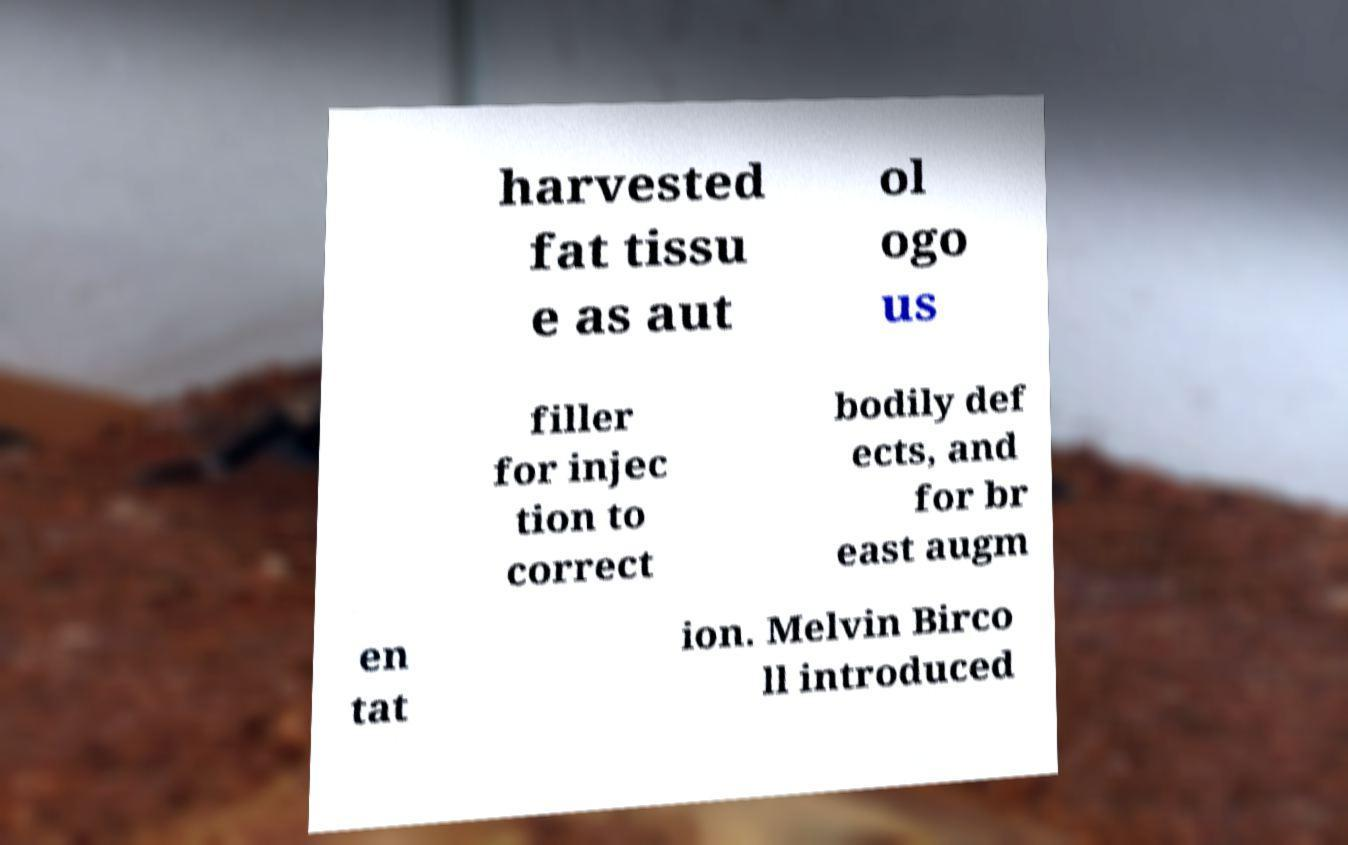I need the written content from this picture converted into text. Can you do that? harvested fat tissu e as aut ol ogo us filler for injec tion to correct bodily def ects, and for br east augm en tat ion. Melvin Birco ll introduced 